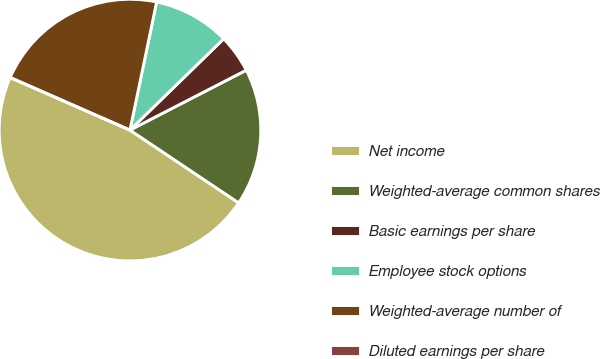Convert chart. <chart><loc_0><loc_0><loc_500><loc_500><pie_chart><fcel>Net income<fcel>Weighted-average common shares<fcel>Basic earnings per share<fcel>Employee stock options<fcel>Weighted-average number of<fcel>Diluted earnings per share<nl><fcel>47.19%<fcel>16.96%<fcel>4.72%<fcel>9.44%<fcel>21.68%<fcel>0.0%<nl></chart> 